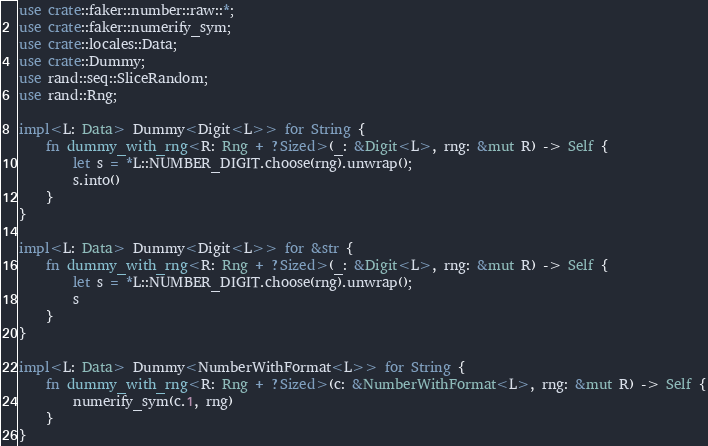Convert code to text. <code><loc_0><loc_0><loc_500><loc_500><_Rust_>use crate::faker::number::raw::*;
use crate::faker::numerify_sym;
use crate::locales::Data;
use crate::Dummy;
use rand::seq::SliceRandom;
use rand::Rng;

impl<L: Data> Dummy<Digit<L>> for String {
    fn dummy_with_rng<R: Rng + ?Sized>(_: &Digit<L>, rng: &mut R) -> Self {
        let s = *L::NUMBER_DIGIT.choose(rng).unwrap();
        s.into()
    }
}

impl<L: Data> Dummy<Digit<L>> for &str {
    fn dummy_with_rng<R: Rng + ?Sized>(_: &Digit<L>, rng: &mut R) -> Self {
        let s = *L::NUMBER_DIGIT.choose(rng).unwrap();
        s
    }
}

impl<L: Data> Dummy<NumberWithFormat<L>> for String {
    fn dummy_with_rng<R: Rng + ?Sized>(c: &NumberWithFormat<L>, rng: &mut R) -> Self {
        numerify_sym(c.1, rng)
    }
}
</code> 